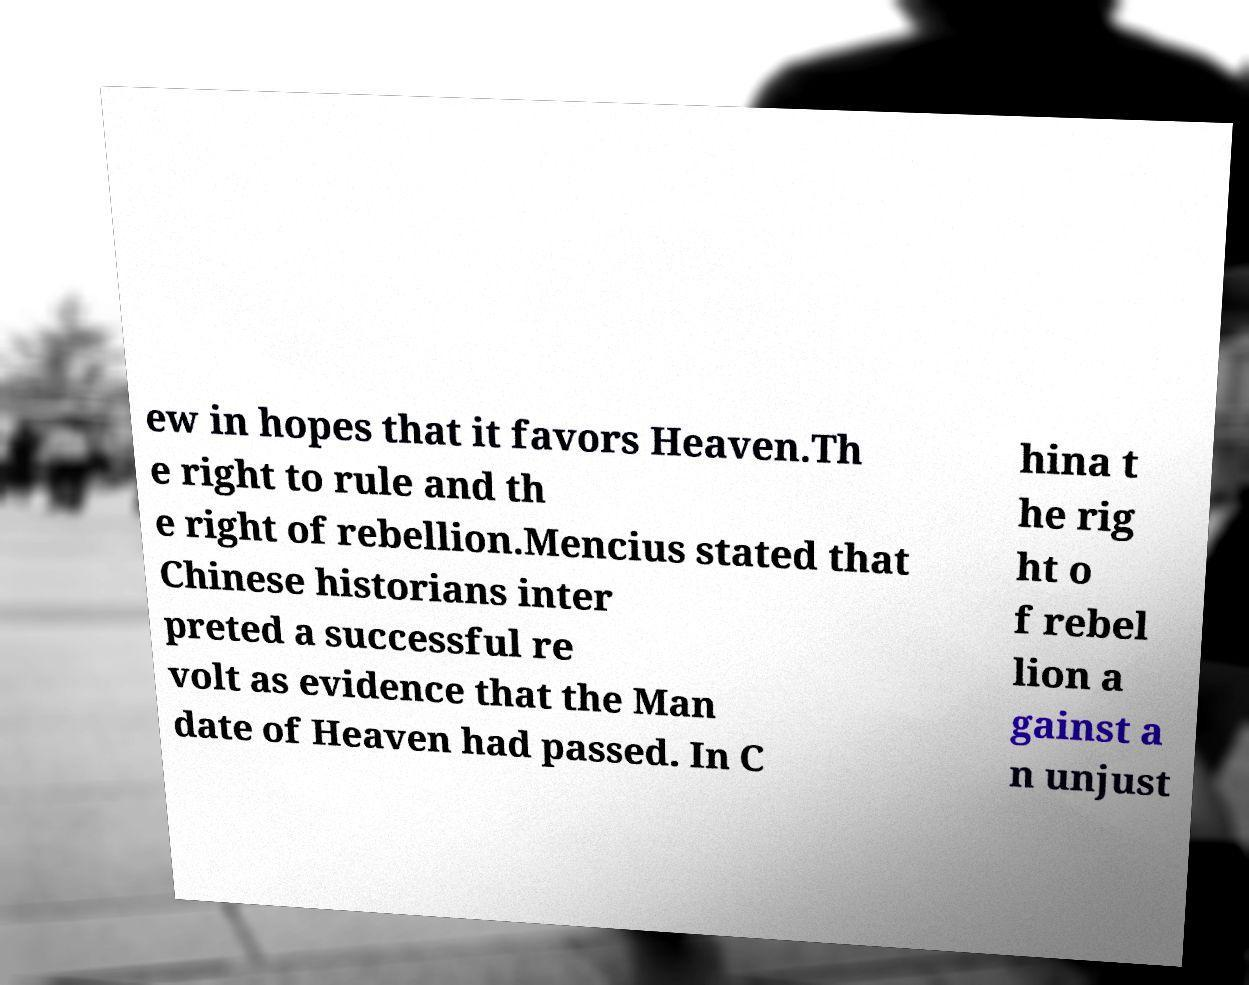Please read and relay the text visible in this image. What does it say? ew in hopes that it favors Heaven.Th e right to rule and th e right of rebellion.Mencius stated that Chinese historians inter preted a successful re volt as evidence that the Man date of Heaven had passed. In C hina t he rig ht o f rebel lion a gainst a n unjust 